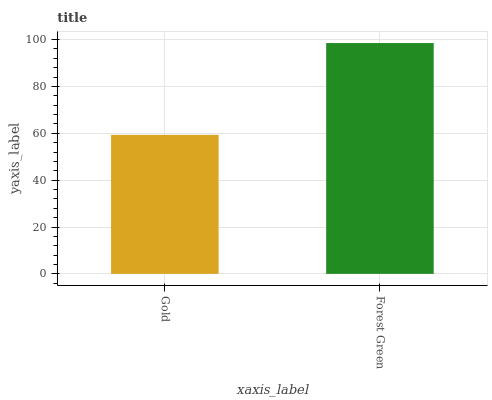Is Gold the minimum?
Answer yes or no. Yes. Is Forest Green the maximum?
Answer yes or no. Yes. Is Forest Green the minimum?
Answer yes or no. No. Is Forest Green greater than Gold?
Answer yes or no. Yes. Is Gold less than Forest Green?
Answer yes or no. Yes. Is Gold greater than Forest Green?
Answer yes or no. No. Is Forest Green less than Gold?
Answer yes or no. No. Is Forest Green the high median?
Answer yes or no. Yes. Is Gold the low median?
Answer yes or no. Yes. Is Gold the high median?
Answer yes or no. No. Is Forest Green the low median?
Answer yes or no. No. 